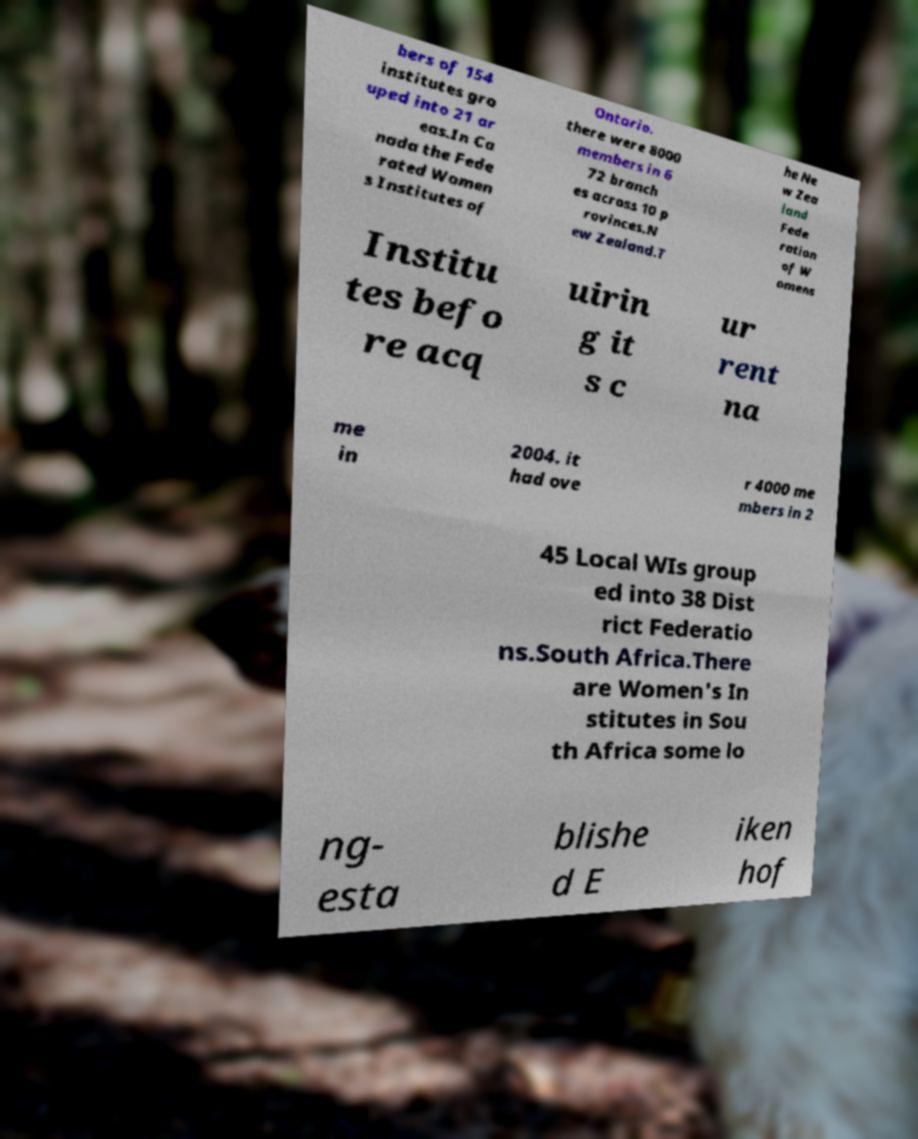Could you extract and type out the text from this image? bers of 154 institutes gro uped into 21 ar eas.In Ca nada the Fede rated Women s Institutes of Ontario. there were 8000 members in 6 72 branch es across 10 p rovinces.N ew Zealand.T he Ne w Zea land Fede ration of W omens Institu tes befo re acq uirin g it s c ur rent na me in 2004. it had ove r 4000 me mbers in 2 45 Local WIs group ed into 38 Dist rict Federatio ns.South Africa.There are Women's In stitutes in Sou th Africa some lo ng- esta blishe d E iken hof 